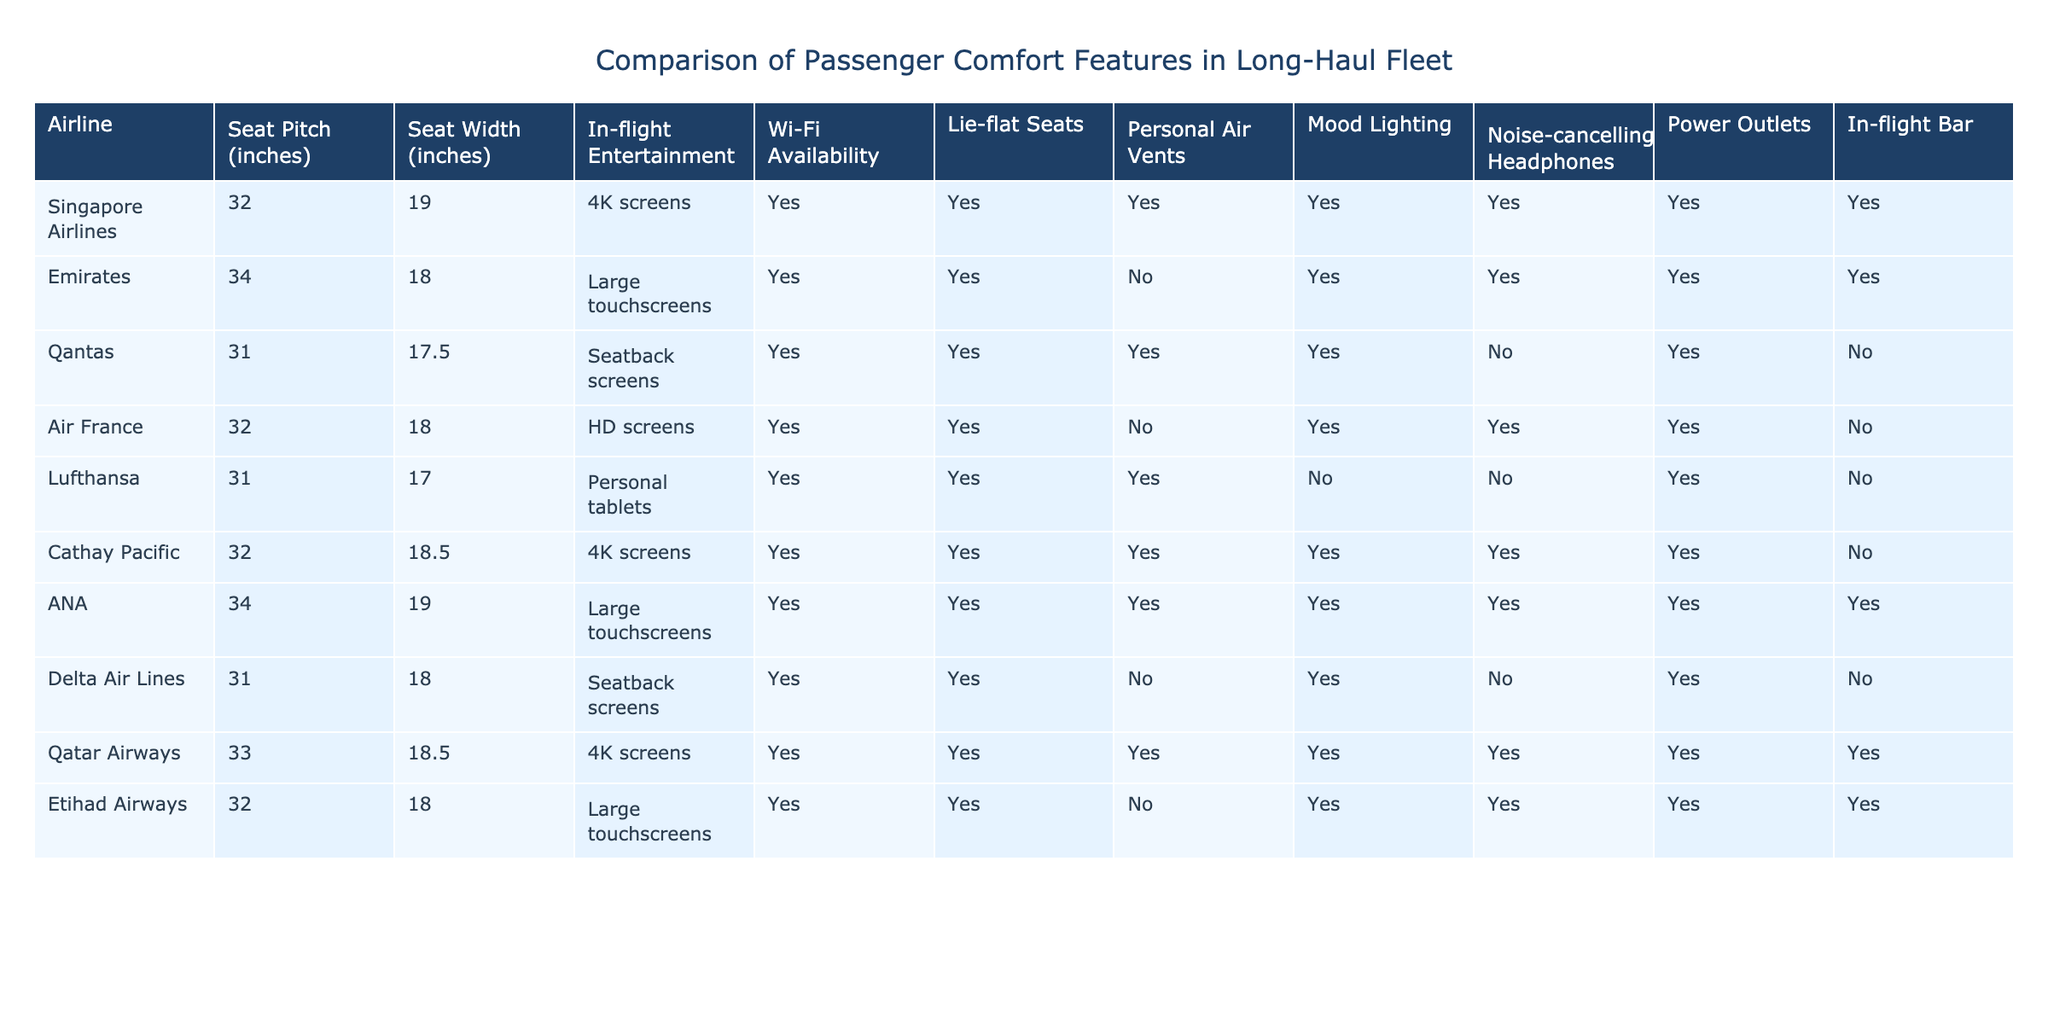What is the seat pitch of Emirates? The table lists Emirates with a seat pitch of 34 inches. This is directly mentioned in the corresponding row for Emirates.
Answer: 34 inches Which airlines offer Wi-Fi availability? The table shows that all airlines except for Lufthansa and Delta Air Lines offer Wi-Fi availability, as indicated by "Yes" in their respective rows.
Answer: Six airlines offer Wi-Fi What is the average seat width among the airlines listed? To find the average seat width, we add the seat widths: (19 + 18 + 17.5 + 18 + 17 + 18.5 + 19 + 18.5 + 18 + 18) = 180.5 inches. There are 10 airlines, so the average is 180.5/10 = 18.05 inches.
Answer: 18.05 inches Does Qatar Airways provide lie-flat seats? In the Qatar Airways row, it is stated that there are lie-flat seats with a "Yes" under the relevant column.
Answer: Yes Which airline has the largest seat pitch? Comparing the seat pitches, ANA and Emirates both have the largest at 34 inches. Thus, ANA and Emirates are the answers.
Answer: Emirates and ANA How many airlines have noise-cancelling headphones available? By checking the "Noise-cancelling Headphones" column, we see Yes marked for Singapore Airlines, Emirates, Qantas, Cathay Pacific, Qatar Airways, and Etihad Airways, making a total of six airlines.
Answer: Six airlines Which airlines do not have personal air vents? The airlines that do not have personal air vents are Lufthansa and Qantas, as indicated by a "No" in their respective rows under the "Personal Air Vents" column.
Answer: Lufthansa and Qantas Identify the common factors among the airlines that have a 4K in-flight entertainment system. The airlines providing 4K screens are Singapore Airlines, Cathay Pacific, and Qatar Airways. They also all offer Wi-Fi, lie-flat seats, and power outlets, indicating a focus on premium comfort.
Answer: Singapore Airlines, Cathay Pacific, Qatar Airways What is the total number of airlines with in-flight bars? By reviewing the "In-flight Bar" column, we find that six airlines—Singapore Airlines, Emirates, ANA, Qatar Airways, Etihad Airways—offer an in-flight bar feature, allowing for a beverage experience during the flight.
Answer: Five airlines 